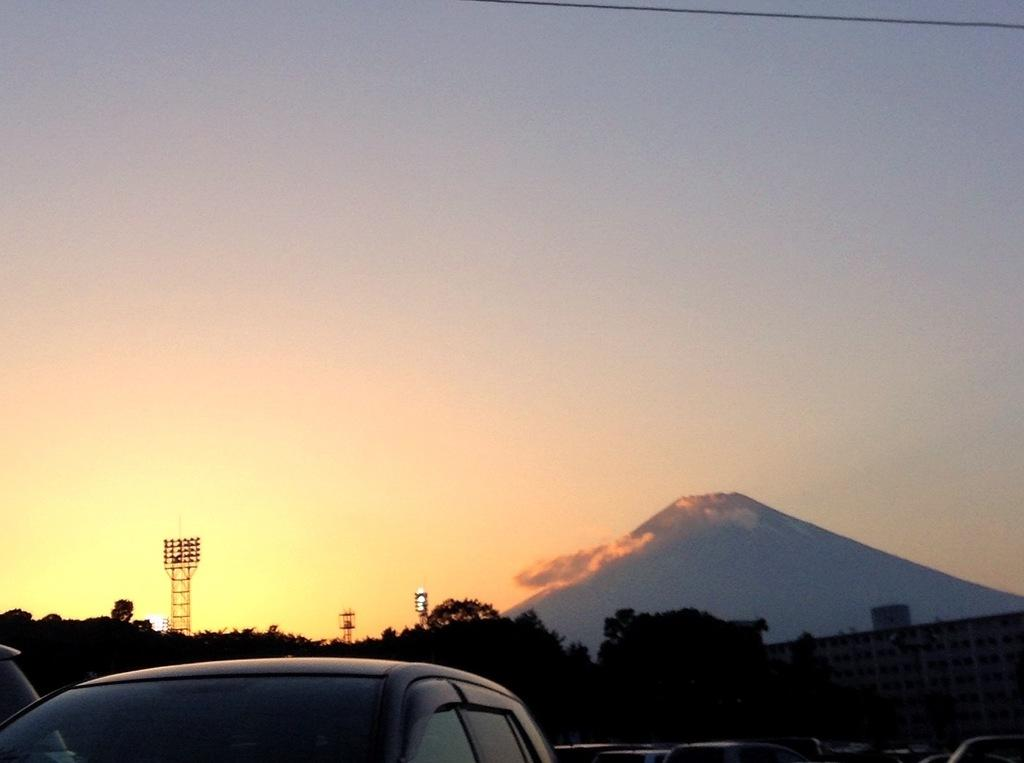What type of vehicles can be seen in the image? There are cars in the image. What other objects are present in the image besides cars? There are drums in the image. What natural feature is on the right side of the image? There is a mountain on the right side of the image. What is visible in the background of the image? There is a sky visible in the background of the image. How many women are holding paper in the image? There are no women or paper present in the image. 